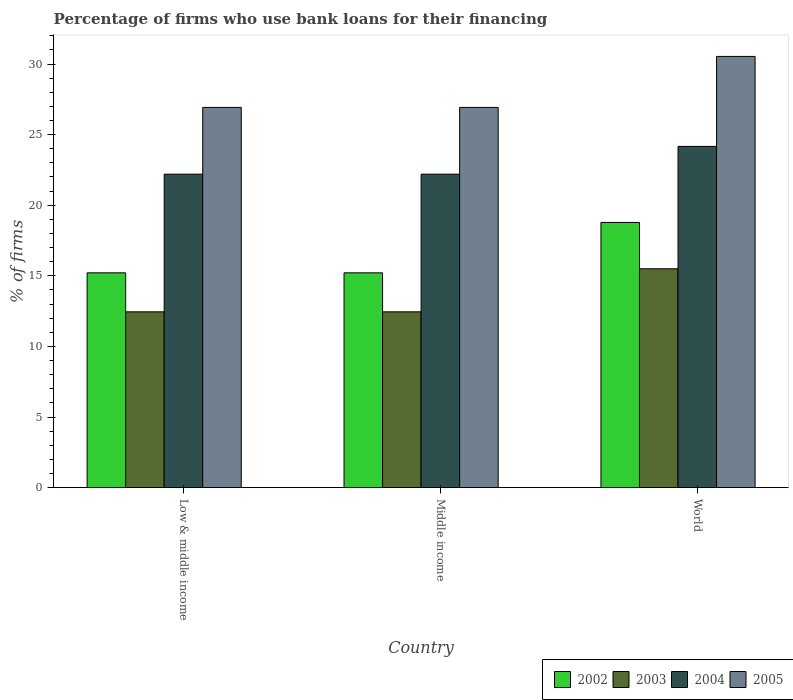How many different coloured bars are there?
Provide a short and direct response. 4. How many groups of bars are there?
Your answer should be very brief. 3. Are the number of bars per tick equal to the number of legend labels?
Ensure brevity in your answer.  Yes. Are the number of bars on each tick of the X-axis equal?
Provide a short and direct response. Yes. What is the label of the 3rd group of bars from the left?
Your answer should be compact. World. In how many cases, is the number of bars for a given country not equal to the number of legend labels?
Ensure brevity in your answer.  0. What is the percentage of firms who use bank loans for their financing in 2002 in Middle income?
Provide a succinct answer. 15.21. Across all countries, what is the minimum percentage of firms who use bank loans for their financing in 2002?
Your response must be concise. 15.21. In which country was the percentage of firms who use bank loans for their financing in 2002 maximum?
Ensure brevity in your answer.  World. What is the total percentage of firms who use bank loans for their financing in 2004 in the graph?
Offer a terse response. 68.57. What is the difference between the percentage of firms who use bank loans for their financing in 2003 in Middle income and that in World?
Ensure brevity in your answer.  -3.05. What is the difference between the percentage of firms who use bank loans for their financing in 2003 in Low & middle income and the percentage of firms who use bank loans for their financing in 2002 in Middle income?
Offer a terse response. -2.76. What is the average percentage of firms who use bank loans for their financing in 2003 per country?
Your answer should be very brief. 13.47. What is the difference between the percentage of firms who use bank loans for their financing of/in 2002 and percentage of firms who use bank loans for their financing of/in 2003 in Middle income?
Give a very brief answer. 2.76. In how many countries, is the percentage of firms who use bank loans for their financing in 2004 greater than 13 %?
Give a very brief answer. 3. What is the ratio of the percentage of firms who use bank loans for their financing in 2002 in Low & middle income to that in World?
Ensure brevity in your answer.  0.81. Is the percentage of firms who use bank loans for their financing in 2005 in Low & middle income less than that in World?
Your answer should be compact. Yes. What is the difference between the highest and the second highest percentage of firms who use bank loans for their financing in 2002?
Offer a terse response. 3.57. What is the difference between the highest and the lowest percentage of firms who use bank loans for their financing in 2002?
Offer a terse response. 3.57. In how many countries, is the percentage of firms who use bank loans for their financing in 2005 greater than the average percentage of firms who use bank loans for their financing in 2005 taken over all countries?
Offer a very short reply. 1. What does the 2nd bar from the right in Low & middle income represents?
Provide a short and direct response. 2004. Is it the case that in every country, the sum of the percentage of firms who use bank loans for their financing in 2002 and percentage of firms who use bank loans for their financing in 2005 is greater than the percentage of firms who use bank loans for their financing in 2004?
Your answer should be compact. Yes. Are all the bars in the graph horizontal?
Offer a terse response. No. Are the values on the major ticks of Y-axis written in scientific E-notation?
Make the answer very short. No. Does the graph contain any zero values?
Make the answer very short. No. What is the title of the graph?
Make the answer very short. Percentage of firms who use bank loans for their financing. Does "1976" appear as one of the legend labels in the graph?
Your response must be concise. No. What is the label or title of the X-axis?
Offer a very short reply. Country. What is the label or title of the Y-axis?
Provide a succinct answer. % of firms. What is the % of firms in 2002 in Low & middle income?
Offer a very short reply. 15.21. What is the % of firms in 2003 in Low & middle income?
Make the answer very short. 12.45. What is the % of firms in 2004 in Low & middle income?
Provide a short and direct response. 22.2. What is the % of firms in 2005 in Low & middle income?
Your answer should be compact. 26.93. What is the % of firms of 2002 in Middle income?
Your response must be concise. 15.21. What is the % of firms in 2003 in Middle income?
Your answer should be compact. 12.45. What is the % of firms in 2004 in Middle income?
Provide a short and direct response. 22.2. What is the % of firms of 2005 in Middle income?
Keep it short and to the point. 26.93. What is the % of firms in 2002 in World?
Keep it short and to the point. 18.78. What is the % of firms of 2004 in World?
Provide a short and direct response. 24.17. What is the % of firms in 2005 in World?
Offer a terse response. 30.54. Across all countries, what is the maximum % of firms of 2002?
Provide a succinct answer. 18.78. Across all countries, what is the maximum % of firms in 2004?
Give a very brief answer. 24.17. Across all countries, what is the maximum % of firms in 2005?
Keep it short and to the point. 30.54. Across all countries, what is the minimum % of firms of 2002?
Provide a succinct answer. 15.21. Across all countries, what is the minimum % of firms in 2003?
Offer a terse response. 12.45. Across all countries, what is the minimum % of firms of 2005?
Your answer should be very brief. 26.93. What is the total % of firms of 2002 in the graph?
Your answer should be compact. 49.21. What is the total % of firms in 2003 in the graph?
Your answer should be very brief. 40.4. What is the total % of firms of 2004 in the graph?
Offer a terse response. 68.57. What is the total % of firms in 2005 in the graph?
Your answer should be compact. 84.39. What is the difference between the % of firms in 2002 in Low & middle income and that in Middle income?
Give a very brief answer. 0. What is the difference between the % of firms in 2003 in Low & middle income and that in Middle income?
Offer a terse response. 0. What is the difference between the % of firms of 2004 in Low & middle income and that in Middle income?
Provide a short and direct response. 0. What is the difference between the % of firms in 2002 in Low & middle income and that in World?
Give a very brief answer. -3.57. What is the difference between the % of firms in 2003 in Low & middle income and that in World?
Offer a very short reply. -3.05. What is the difference between the % of firms of 2004 in Low & middle income and that in World?
Provide a succinct answer. -1.97. What is the difference between the % of firms of 2005 in Low & middle income and that in World?
Make the answer very short. -3.61. What is the difference between the % of firms of 2002 in Middle income and that in World?
Give a very brief answer. -3.57. What is the difference between the % of firms of 2003 in Middle income and that in World?
Give a very brief answer. -3.05. What is the difference between the % of firms of 2004 in Middle income and that in World?
Ensure brevity in your answer.  -1.97. What is the difference between the % of firms of 2005 in Middle income and that in World?
Provide a succinct answer. -3.61. What is the difference between the % of firms of 2002 in Low & middle income and the % of firms of 2003 in Middle income?
Keep it short and to the point. 2.76. What is the difference between the % of firms in 2002 in Low & middle income and the % of firms in 2004 in Middle income?
Keep it short and to the point. -6.99. What is the difference between the % of firms in 2002 in Low & middle income and the % of firms in 2005 in Middle income?
Ensure brevity in your answer.  -11.72. What is the difference between the % of firms of 2003 in Low & middle income and the % of firms of 2004 in Middle income?
Your answer should be compact. -9.75. What is the difference between the % of firms in 2003 in Low & middle income and the % of firms in 2005 in Middle income?
Ensure brevity in your answer.  -14.48. What is the difference between the % of firms in 2004 in Low & middle income and the % of firms in 2005 in Middle income?
Your response must be concise. -4.73. What is the difference between the % of firms in 2002 in Low & middle income and the % of firms in 2003 in World?
Provide a succinct answer. -0.29. What is the difference between the % of firms in 2002 in Low & middle income and the % of firms in 2004 in World?
Your answer should be compact. -8.95. What is the difference between the % of firms in 2002 in Low & middle income and the % of firms in 2005 in World?
Give a very brief answer. -15.33. What is the difference between the % of firms in 2003 in Low & middle income and the % of firms in 2004 in World?
Offer a very short reply. -11.72. What is the difference between the % of firms of 2003 in Low & middle income and the % of firms of 2005 in World?
Provide a short and direct response. -18.09. What is the difference between the % of firms in 2004 in Low & middle income and the % of firms in 2005 in World?
Your answer should be compact. -8.34. What is the difference between the % of firms in 2002 in Middle income and the % of firms in 2003 in World?
Provide a short and direct response. -0.29. What is the difference between the % of firms in 2002 in Middle income and the % of firms in 2004 in World?
Keep it short and to the point. -8.95. What is the difference between the % of firms of 2002 in Middle income and the % of firms of 2005 in World?
Provide a short and direct response. -15.33. What is the difference between the % of firms of 2003 in Middle income and the % of firms of 2004 in World?
Offer a terse response. -11.72. What is the difference between the % of firms in 2003 in Middle income and the % of firms in 2005 in World?
Keep it short and to the point. -18.09. What is the difference between the % of firms of 2004 in Middle income and the % of firms of 2005 in World?
Your response must be concise. -8.34. What is the average % of firms in 2002 per country?
Keep it short and to the point. 16.4. What is the average % of firms of 2003 per country?
Make the answer very short. 13.47. What is the average % of firms of 2004 per country?
Give a very brief answer. 22.86. What is the average % of firms of 2005 per country?
Provide a short and direct response. 28.13. What is the difference between the % of firms of 2002 and % of firms of 2003 in Low & middle income?
Your answer should be very brief. 2.76. What is the difference between the % of firms in 2002 and % of firms in 2004 in Low & middle income?
Provide a succinct answer. -6.99. What is the difference between the % of firms of 2002 and % of firms of 2005 in Low & middle income?
Your response must be concise. -11.72. What is the difference between the % of firms in 2003 and % of firms in 2004 in Low & middle income?
Keep it short and to the point. -9.75. What is the difference between the % of firms in 2003 and % of firms in 2005 in Low & middle income?
Ensure brevity in your answer.  -14.48. What is the difference between the % of firms of 2004 and % of firms of 2005 in Low & middle income?
Offer a terse response. -4.73. What is the difference between the % of firms of 2002 and % of firms of 2003 in Middle income?
Your answer should be compact. 2.76. What is the difference between the % of firms of 2002 and % of firms of 2004 in Middle income?
Keep it short and to the point. -6.99. What is the difference between the % of firms of 2002 and % of firms of 2005 in Middle income?
Keep it short and to the point. -11.72. What is the difference between the % of firms of 2003 and % of firms of 2004 in Middle income?
Provide a succinct answer. -9.75. What is the difference between the % of firms of 2003 and % of firms of 2005 in Middle income?
Keep it short and to the point. -14.48. What is the difference between the % of firms in 2004 and % of firms in 2005 in Middle income?
Your answer should be compact. -4.73. What is the difference between the % of firms in 2002 and % of firms in 2003 in World?
Offer a terse response. 3.28. What is the difference between the % of firms in 2002 and % of firms in 2004 in World?
Provide a succinct answer. -5.39. What is the difference between the % of firms in 2002 and % of firms in 2005 in World?
Offer a very short reply. -11.76. What is the difference between the % of firms in 2003 and % of firms in 2004 in World?
Your response must be concise. -8.67. What is the difference between the % of firms of 2003 and % of firms of 2005 in World?
Keep it short and to the point. -15.04. What is the difference between the % of firms of 2004 and % of firms of 2005 in World?
Your response must be concise. -6.37. What is the ratio of the % of firms in 2002 in Low & middle income to that in Middle income?
Give a very brief answer. 1. What is the ratio of the % of firms of 2003 in Low & middle income to that in Middle income?
Keep it short and to the point. 1. What is the ratio of the % of firms of 2004 in Low & middle income to that in Middle income?
Offer a very short reply. 1. What is the ratio of the % of firms of 2002 in Low & middle income to that in World?
Offer a terse response. 0.81. What is the ratio of the % of firms of 2003 in Low & middle income to that in World?
Provide a succinct answer. 0.8. What is the ratio of the % of firms in 2004 in Low & middle income to that in World?
Offer a terse response. 0.92. What is the ratio of the % of firms of 2005 in Low & middle income to that in World?
Make the answer very short. 0.88. What is the ratio of the % of firms of 2002 in Middle income to that in World?
Provide a short and direct response. 0.81. What is the ratio of the % of firms of 2003 in Middle income to that in World?
Keep it short and to the point. 0.8. What is the ratio of the % of firms in 2004 in Middle income to that in World?
Give a very brief answer. 0.92. What is the ratio of the % of firms of 2005 in Middle income to that in World?
Keep it short and to the point. 0.88. What is the difference between the highest and the second highest % of firms in 2002?
Your answer should be very brief. 3.57. What is the difference between the highest and the second highest % of firms in 2003?
Your answer should be compact. 3.05. What is the difference between the highest and the second highest % of firms of 2004?
Your answer should be compact. 1.97. What is the difference between the highest and the second highest % of firms in 2005?
Ensure brevity in your answer.  3.61. What is the difference between the highest and the lowest % of firms in 2002?
Provide a succinct answer. 3.57. What is the difference between the highest and the lowest % of firms of 2003?
Provide a succinct answer. 3.05. What is the difference between the highest and the lowest % of firms in 2004?
Your answer should be compact. 1.97. What is the difference between the highest and the lowest % of firms of 2005?
Your answer should be compact. 3.61. 